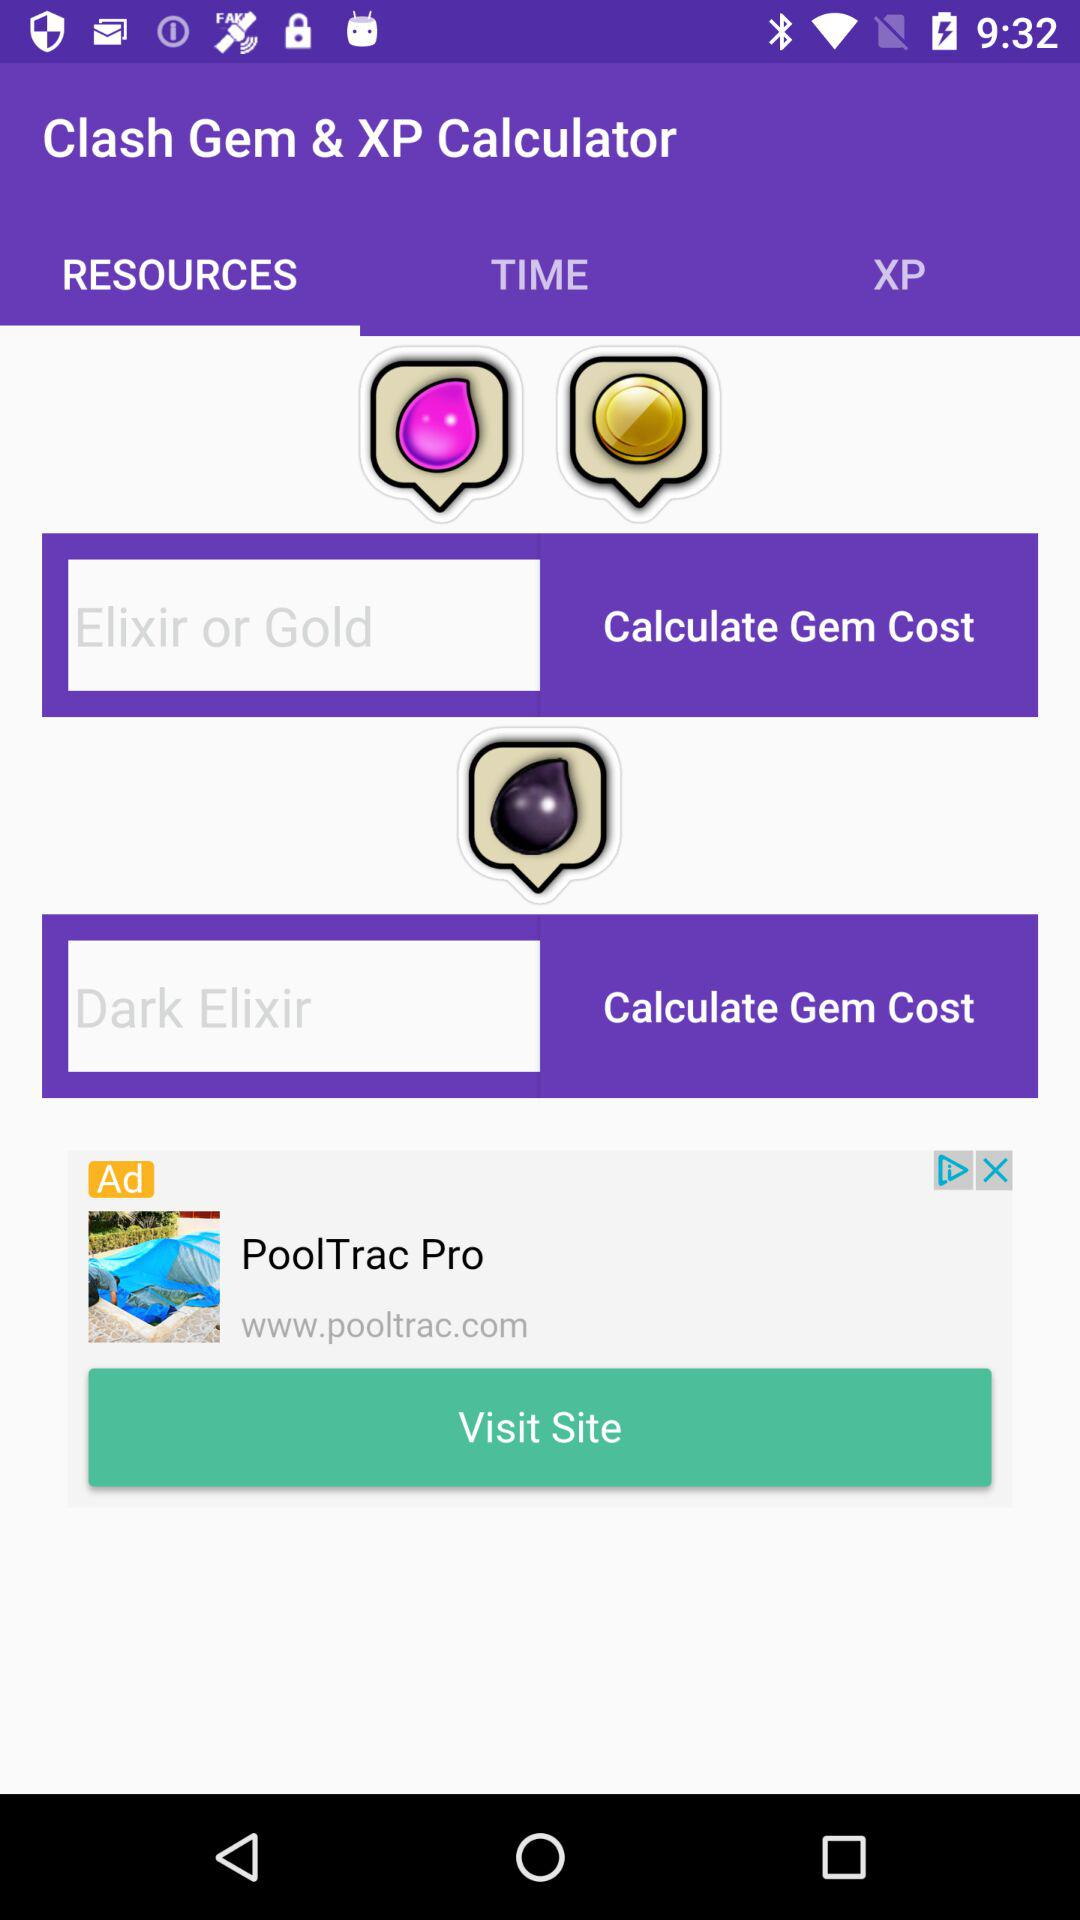What is the application name? The application name is "Clash Gem & XP Calculator". 